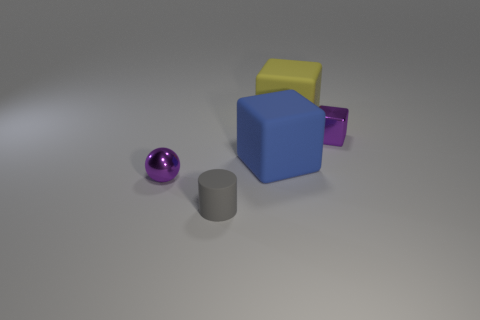Are there more large cubes that are in front of the yellow rubber object than purple objects to the right of the small gray cylinder?
Your answer should be very brief. No. Is the small purple ball made of the same material as the tiny object that is right of the yellow object?
Keep it short and to the point. Yes. What color is the metallic sphere?
Your response must be concise. Purple. What shape is the small thing that is right of the gray matte cylinder?
Offer a very short reply. Cube. How many red objects are large blocks or matte things?
Your response must be concise. 0. What is the color of the tiny cylinder that is made of the same material as the big yellow block?
Make the answer very short. Gray. There is a sphere; is its color the same as the metal object on the right side of the small cylinder?
Offer a terse response. Yes. What is the color of the small thing that is behind the small matte cylinder and left of the metal block?
Offer a very short reply. Purple. There is a small purple cube; how many large rubber blocks are in front of it?
Keep it short and to the point. 1. What number of things are either matte cylinders or big matte blocks that are to the left of the big yellow block?
Provide a short and direct response. 2. 